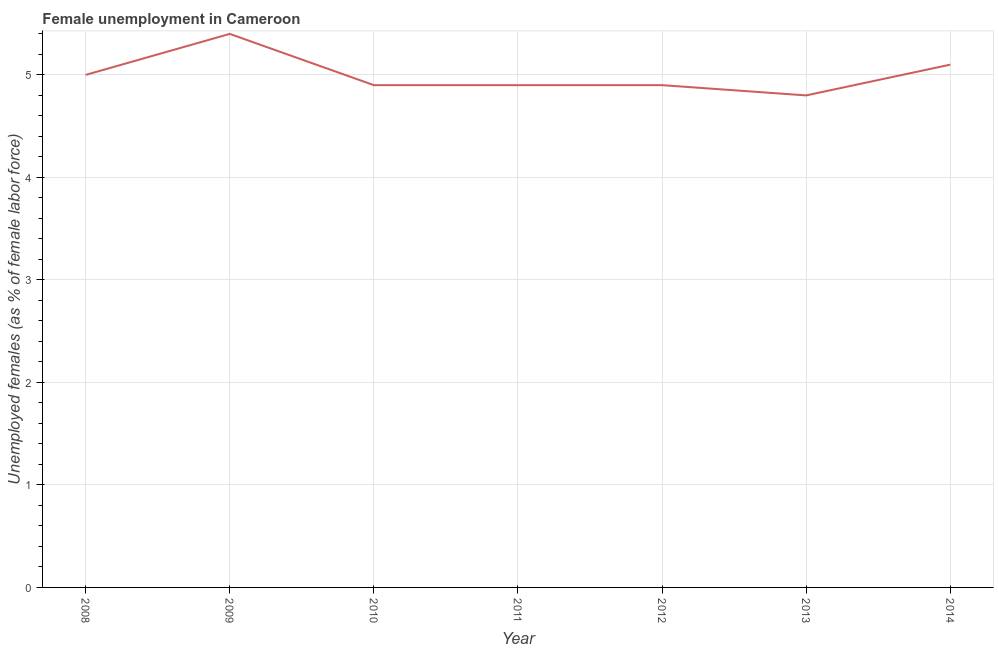What is the unemployed females population in 2011?
Offer a very short reply. 4.9. Across all years, what is the maximum unemployed females population?
Make the answer very short. 5.4. Across all years, what is the minimum unemployed females population?
Provide a short and direct response. 4.8. What is the sum of the unemployed females population?
Provide a succinct answer. 35. What is the difference between the unemployed females population in 2011 and 2014?
Provide a succinct answer. -0.2. What is the average unemployed females population per year?
Your answer should be compact. 5. What is the median unemployed females population?
Offer a very short reply. 4.9. What is the ratio of the unemployed females population in 2009 to that in 2013?
Your answer should be compact. 1.12. Is the difference between the unemployed females population in 2013 and 2014 greater than the difference between any two years?
Your response must be concise. No. What is the difference between the highest and the second highest unemployed females population?
Your response must be concise. 0.3. Is the sum of the unemployed females population in 2011 and 2014 greater than the maximum unemployed females population across all years?
Your answer should be compact. Yes. What is the difference between the highest and the lowest unemployed females population?
Provide a short and direct response. 0.6. In how many years, is the unemployed females population greater than the average unemployed females population taken over all years?
Ensure brevity in your answer.  2. How many years are there in the graph?
Provide a short and direct response. 7. Are the values on the major ticks of Y-axis written in scientific E-notation?
Keep it short and to the point. No. Does the graph contain grids?
Give a very brief answer. Yes. What is the title of the graph?
Keep it short and to the point. Female unemployment in Cameroon. What is the label or title of the X-axis?
Offer a terse response. Year. What is the label or title of the Y-axis?
Keep it short and to the point. Unemployed females (as % of female labor force). What is the Unemployed females (as % of female labor force) in 2009?
Keep it short and to the point. 5.4. What is the Unemployed females (as % of female labor force) in 2010?
Provide a short and direct response. 4.9. What is the Unemployed females (as % of female labor force) of 2011?
Make the answer very short. 4.9. What is the Unemployed females (as % of female labor force) of 2012?
Provide a succinct answer. 4.9. What is the Unemployed females (as % of female labor force) of 2013?
Ensure brevity in your answer.  4.8. What is the Unemployed females (as % of female labor force) in 2014?
Provide a short and direct response. 5.1. What is the difference between the Unemployed females (as % of female labor force) in 2008 and 2009?
Your response must be concise. -0.4. What is the difference between the Unemployed females (as % of female labor force) in 2008 and 2010?
Ensure brevity in your answer.  0.1. What is the difference between the Unemployed females (as % of female labor force) in 2008 and 2011?
Provide a short and direct response. 0.1. What is the difference between the Unemployed females (as % of female labor force) in 2008 and 2012?
Give a very brief answer. 0.1. What is the difference between the Unemployed females (as % of female labor force) in 2009 and 2010?
Offer a terse response. 0.5. What is the difference between the Unemployed females (as % of female labor force) in 2011 and 2012?
Your answer should be compact. 0. What is the difference between the Unemployed females (as % of female labor force) in 2012 and 2013?
Offer a terse response. 0.1. What is the difference between the Unemployed females (as % of female labor force) in 2013 and 2014?
Keep it short and to the point. -0.3. What is the ratio of the Unemployed females (as % of female labor force) in 2008 to that in 2009?
Give a very brief answer. 0.93. What is the ratio of the Unemployed females (as % of female labor force) in 2008 to that in 2011?
Provide a short and direct response. 1.02. What is the ratio of the Unemployed females (as % of female labor force) in 2008 to that in 2013?
Your answer should be compact. 1.04. What is the ratio of the Unemployed females (as % of female labor force) in 2008 to that in 2014?
Make the answer very short. 0.98. What is the ratio of the Unemployed females (as % of female labor force) in 2009 to that in 2010?
Your answer should be very brief. 1.1. What is the ratio of the Unemployed females (as % of female labor force) in 2009 to that in 2011?
Make the answer very short. 1.1. What is the ratio of the Unemployed females (as % of female labor force) in 2009 to that in 2012?
Provide a succinct answer. 1.1. What is the ratio of the Unemployed females (as % of female labor force) in 2009 to that in 2014?
Offer a terse response. 1.06. What is the ratio of the Unemployed females (as % of female labor force) in 2010 to that in 2012?
Make the answer very short. 1. What is the ratio of the Unemployed females (as % of female labor force) in 2010 to that in 2013?
Your response must be concise. 1.02. What is the ratio of the Unemployed females (as % of female labor force) in 2011 to that in 2013?
Offer a terse response. 1.02. What is the ratio of the Unemployed females (as % of female labor force) in 2011 to that in 2014?
Make the answer very short. 0.96. What is the ratio of the Unemployed females (as % of female labor force) in 2012 to that in 2013?
Give a very brief answer. 1.02. What is the ratio of the Unemployed females (as % of female labor force) in 2012 to that in 2014?
Offer a terse response. 0.96. What is the ratio of the Unemployed females (as % of female labor force) in 2013 to that in 2014?
Give a very brief answer. 0.94. 